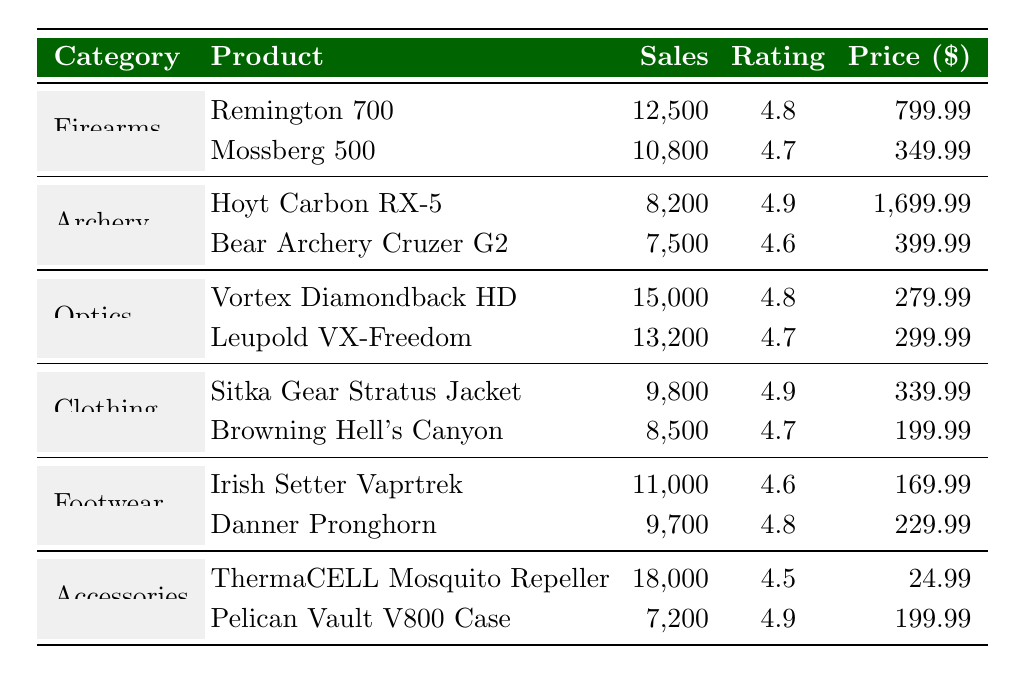What is the highest-rated product in the table? The highest rating in the table is 4.9, which is attributed to two products: the Hoyt Carbon RX-5 and the Sitka Gear Stratus Jacket.
Answer: Hoyt Carbon RX-5 and Sitka Gear Stratus Jacket Which category has the most sales? The category with the most sales is Accessories, with a total of 18,000 units sold for the ThermaCELL Mosquito Repeller.
Answer: Accessories What is the average price of products in the Firearms category? The prices for the firearms are $799.99 for the Remington 700 and $349.99 for the Mossberg 500. The average price is calculated as (799.99 + 349.99) / 2 = 574.99.
Answer: 574.99 How many units were sold in total across all categories? The total sales are calculated by summing the sales from each category: 12500 + 10800 + 8200 + 7500 + 15000 + 13200 + 9800 + 8500 + 11000 + 9700 + 18000 + 7200 = 103,500.
Answer: 103500 What percentage of total sales does the product with the highest sales contribute? The highest sales are 18,000 for the ThermaCELL Mosquito Repeller. To find the percentage, divide 18,000 by the total sales (103,500) and multiply by 100. This gives (18000 / 103500) * 100 ≈ 17.37%.
Answer: 17.37% Is the average rating of the Optics category above or below 4.5? In the Optics category, the Vortex Diamondback HD has a rating of 4.8 and the Leupold VX-Freedom has a rating of 4.7. The average is (4.8 + 4.7) / 2 = 4.75, which is above 4.5.
Answer: Above What is the difference in sales between the highest and lowest-selling product? The highest-selling product is the ThermaCELL Mosquito Repeller with 18,000 units sold, and the lowest-selling product is the Pelican Vault V800 Case with 7,200 units sold. The difference is calculated as 18,000 - 7,200 = 10,800.
Answer: 10800 Which product in the Clothing category has the lowest price? In the Clothing category, the products are the Sitka Gear Stratus Jacket priced at $339.99 and the Browning Hell's Canyon priced at $199.99. The Browning Hell's Canyon has the lowest price.
Answer: Browning Hell's Canyon What is the total sales of the Archery category? For the Archery category, the Hoyt Carbon RX-5 has sales of 8,200 and the Bear Archery Cruzer G2 has sales of 7,500. Adding these gives a total of 8,200 + 7,500 = 15,700.
Answer: 15700 Which category has the least number of products listed in the table? Each category has two products listed in the table, so no category has a lesser number of products. All categories are equally represented.
Answer: None 